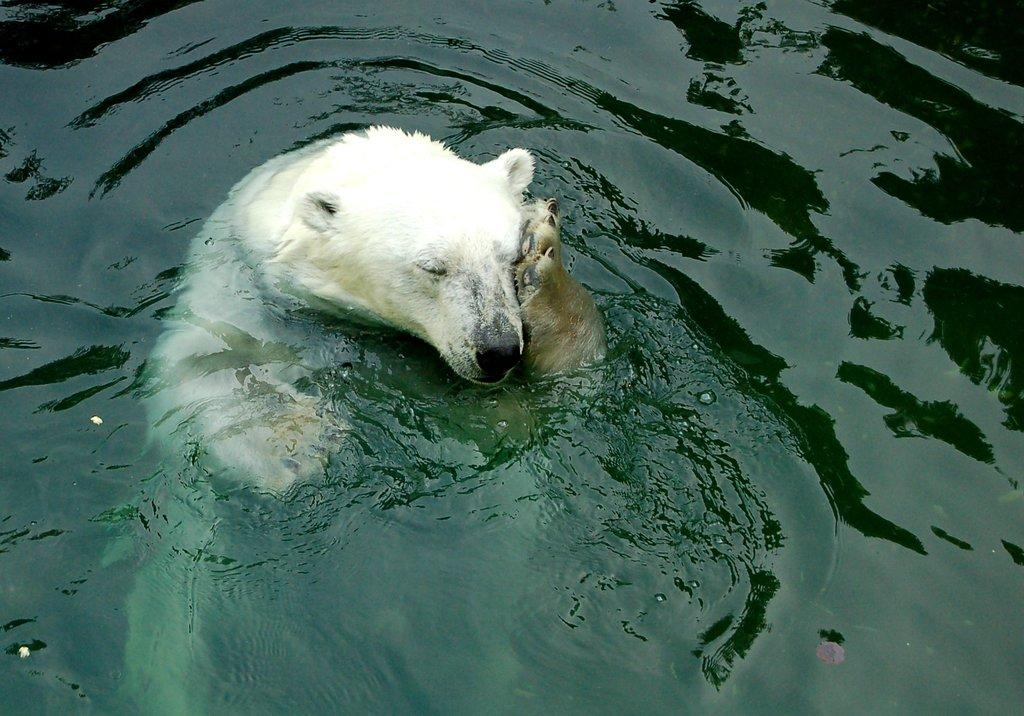What animal is in the water in the image? There is a polar bear in the water in the image. What is the primary element in which the polar bear is situated? The polar bear is situated in water. What type of cable can be seen connecting the polar bear to the secretary in the image? There is no cable or secretary present in the image; it features a polar bear in the water. 